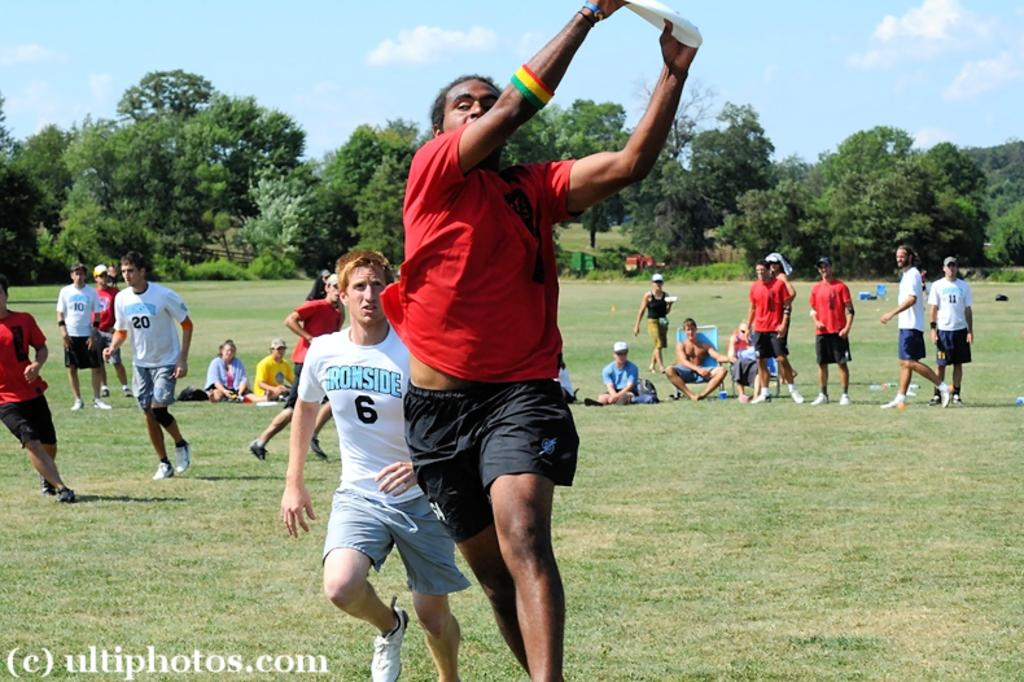<image>
Describe the image concisely. The frisbee player with the white shirt that says Ironside is behind the one with the red shirt. 